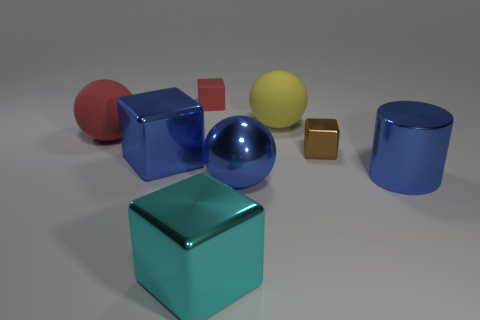Subtract all large blue cubes. How many cubes are left? 3 Add 1 tiny blocks. How many objects exist? 9 Subtract all blue cubes. How many cubes are left? 3 Subtract 1 spheres. How many spheres are left? 2 Add 8 large shiny cubes. How many large shiny cubes exist? 10 Subtract 0 gray blocks. How many objects are left? 8 Subtract all balls. How many objects are left? 5 Subtract all green cylinders. Subtract all brown blocks. How many cylinders are left? 1 Subtract all big shiny balls. Subtract all tiny red cubes. How many objects are left? 6 Add 4 large blue objects. How many large blue objects are left? 7 